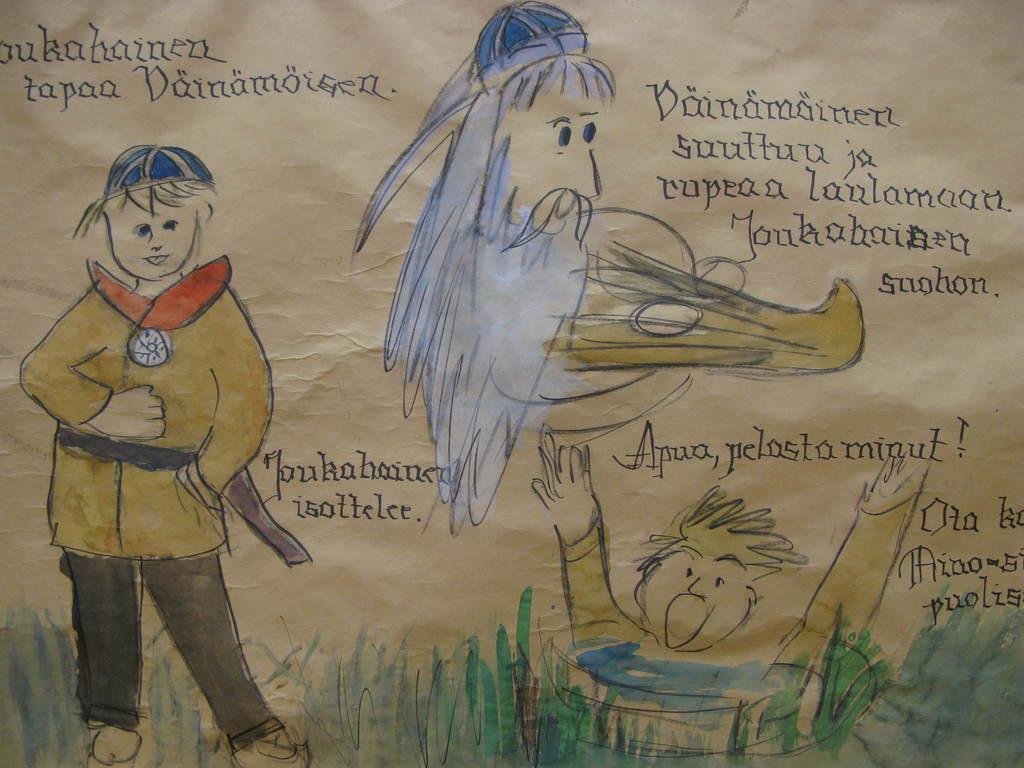How would you summarize this image in a sentence or two? This is a painting on a paper. And something is written on that. On the left side there is a painting of a child. 